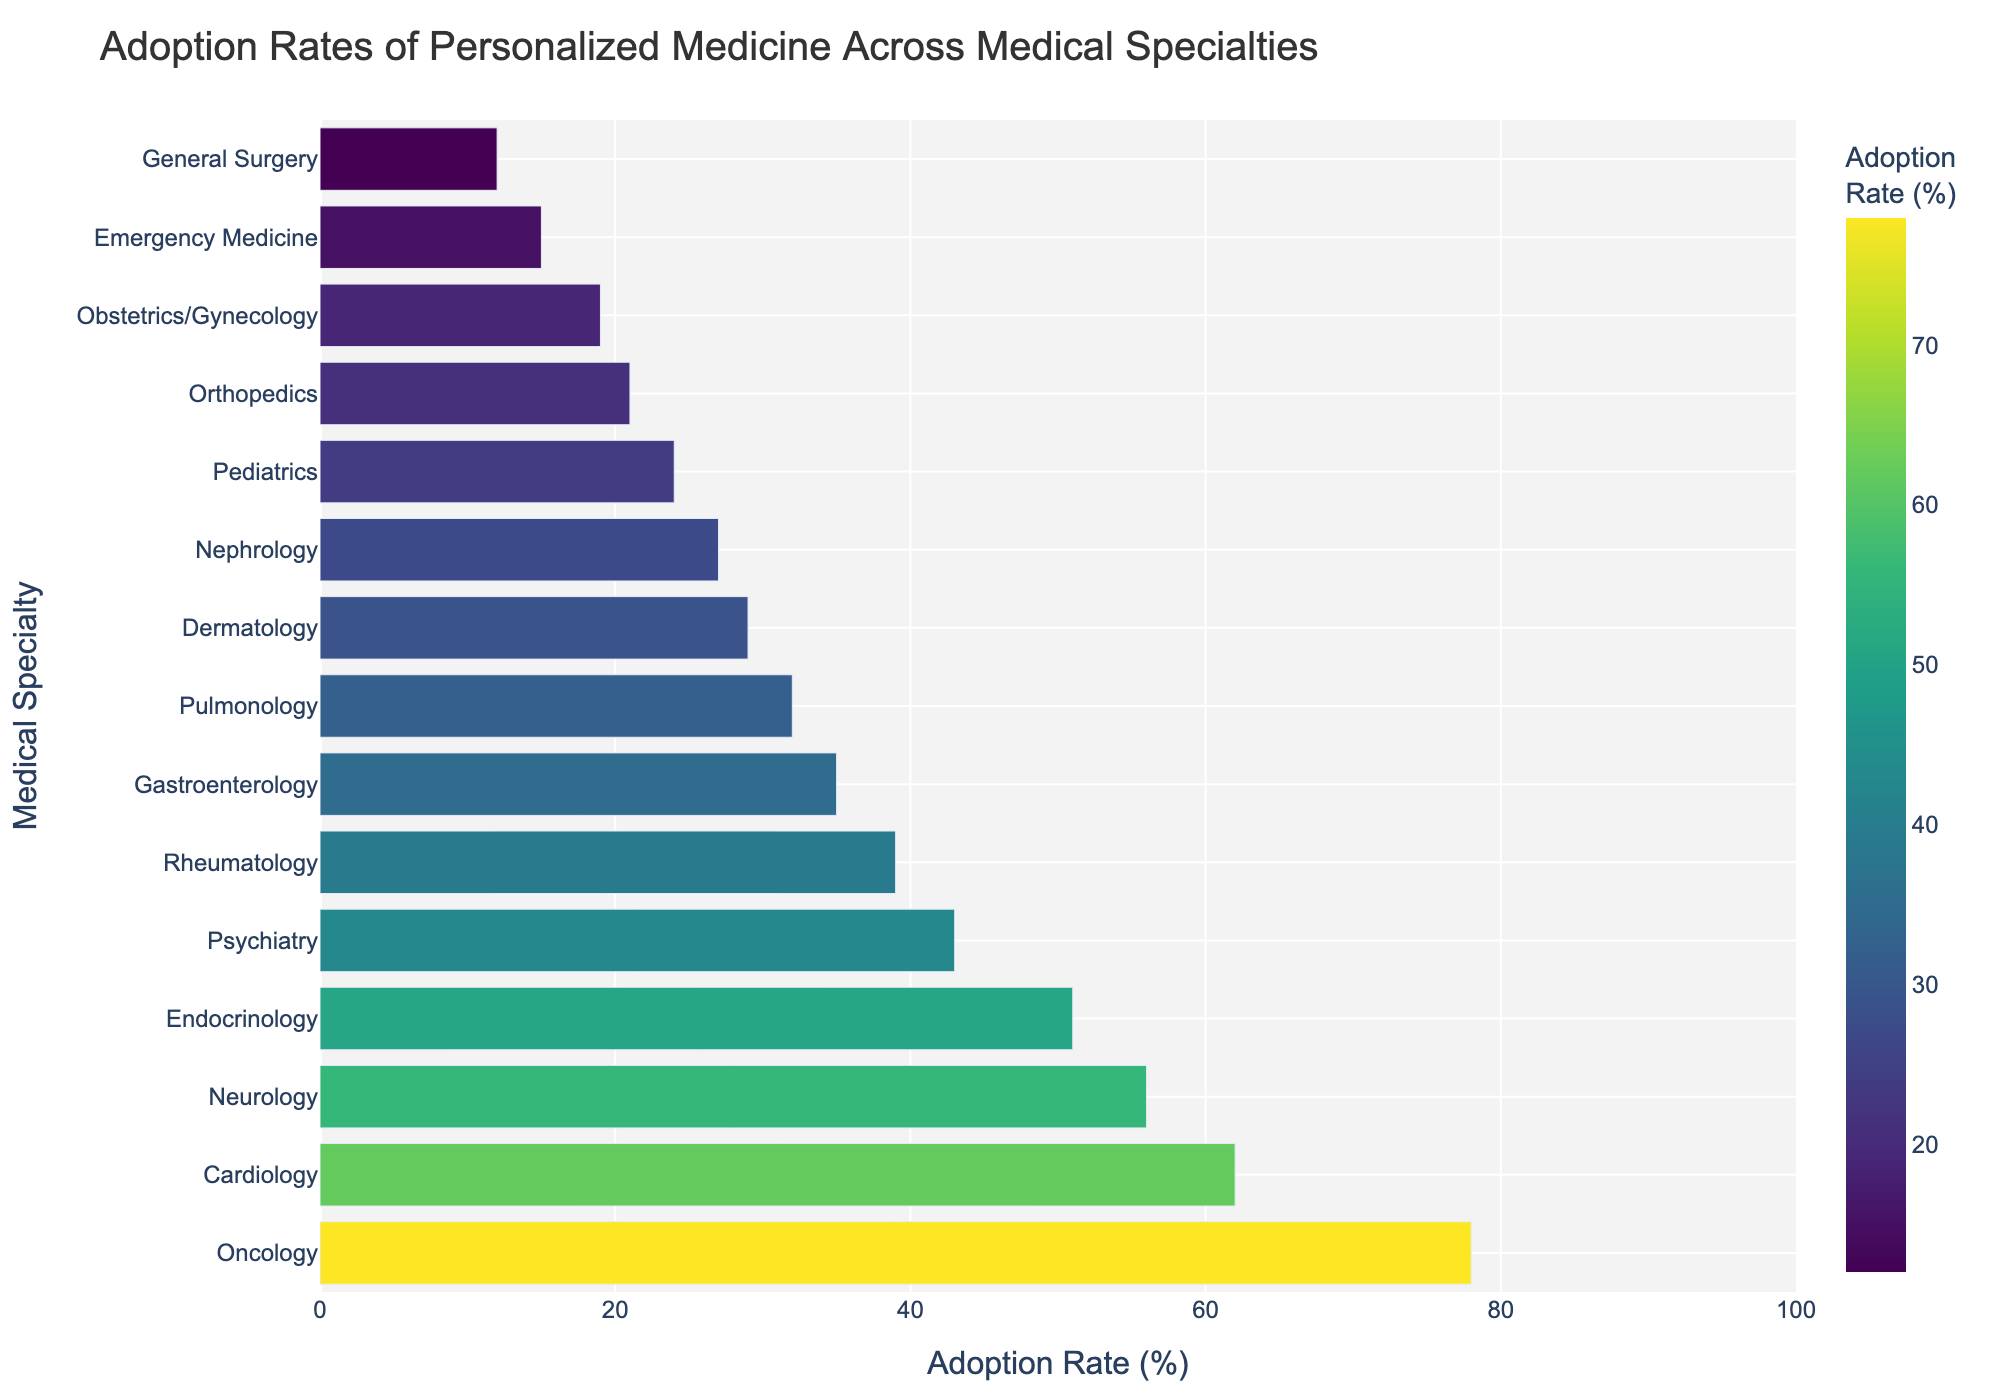What is the specialty with the highest adoption rate of personalized medicine? The figure shows different medical specialties along the y-axis with their respective adoption rates on the x-axis. The longest bar indicates the highest adoption rate.
Answer: Oncology Which specialty has a lower adoption rate of personalized medicine, Dermatology or Nephrology? In the figure, find the bars representing Dermatology and Nephrology and compare their lengths. The bar for Nephrology is shorter than that for Dermatology.
Answer: Nephrology What is the average adoption rate of personalized medicine for Neurology, Endocrinology, and Psychiatry? Find the adoption rates for Neurology (56%), Endocrinology (51%), and Psychiatry (43%) and compute their average: (56 + 51 + 43) / 3.
Answer: 50% Which specialties have an adoption rate of personalized medicine greater than 50%? Look at the bars and note the specialties with adoption rates above the 50% mark. These are Oncology (78%), Cardiology (62%), and Neurology (56%).
Answer: Oncology, Cardiology, Neurology How much higher is the adoption rate of personalized medicine in Cardiology compared to Emergency Medicine? Find the adoption rates for Cardiology (62%) and Emergency Medicine (15%) and calculate the difference: 62 - 15.
Answer: 47% What is the median adoption rate of personalized medicine across all specialties shown in the figure? List all adoption rates and find the middle value in the sorted list. Rates are: 12, 15, 19, 21, 24, 27, 29, 32, 35, 39, 43, 51, 56, 62, 78. The median is the 8th value.
Answer: 35% Between Gastroenterology and Pulmonology, which one has a higher adoption rate of personalized medicine? Compare the lengths of the bars for Gastroenterology and Pulmonology. Gastroenterology has a longer bar.
Answer: Gastroenterology Which specialty has the shortest bar in the figure? The shortest bar represents the specialty with the lowest adoption rate of personalized medicine.
Answer: General Surgery What is the sum of adoption rates for the top three specialties in the figure? Sum the adoption rates of Oncology (78%), Cardiology (62%), and Neurology (56%): 78 + 62 + 56.
Answer: 196% How many specialties have an adoption rate below 30%? Count the bars that are shorter than the 30% mark: Dermatology (29%), Nephrology (27%), Pediatrics (24%), Orthopedics (21%), Obstetrics/Gynecology (19%), Emergency Medicine (15%), General Surgery (12%).
Answer: 7 